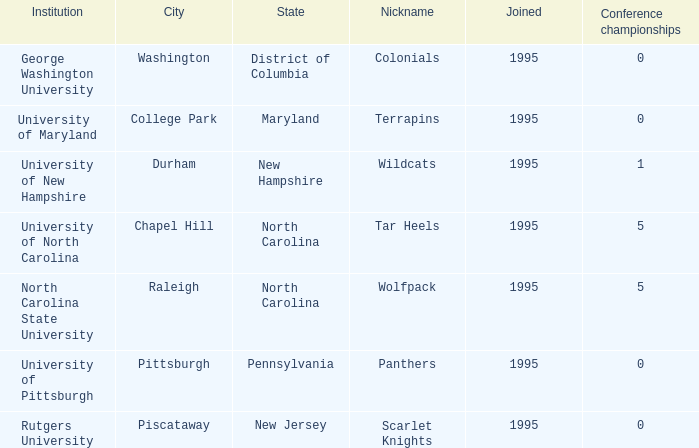What is the smallest year joined in the city of college park at the conference championships below 0? None. 